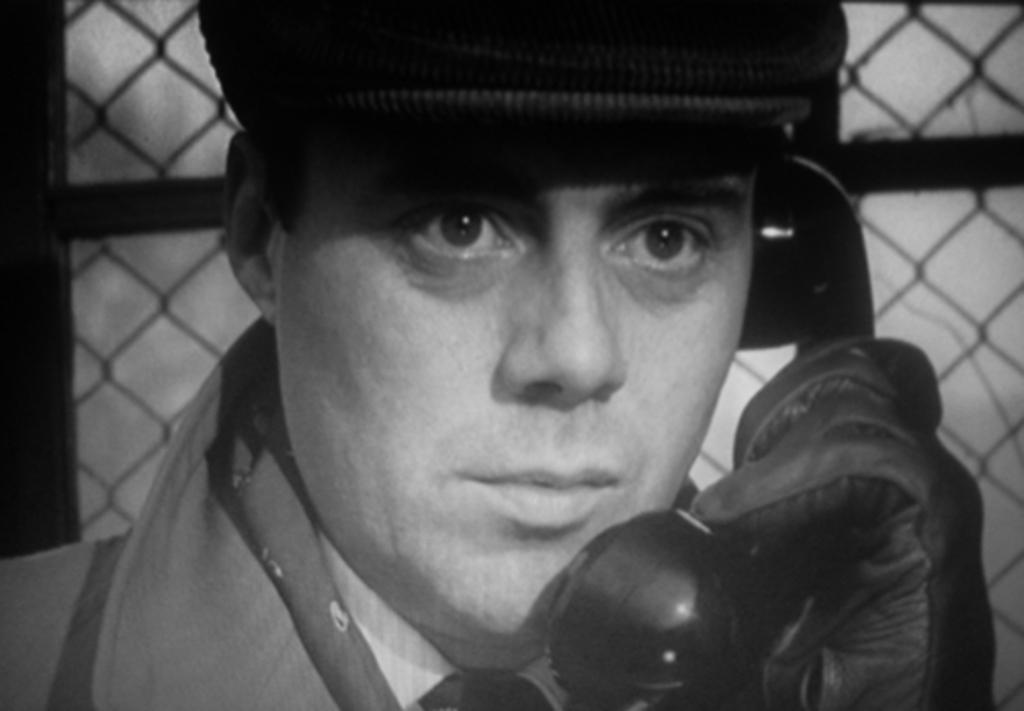Who is the main subject in the image? There is a person in the center of the image. What is the person wearing on their head? The person is wearing a hat. What else is the person wearing? The person is wearing gloves. What object is the person holding? The person is holding a telephone. What can be seen in the background of the image? There is mesh in the background of the image. How many passengers are visible in the image? There are no passengers visible in the image; it only features a person holding a telephone. What type of button is the beginner learning to sew in the image? There is no button or sewing activity present in the image. 